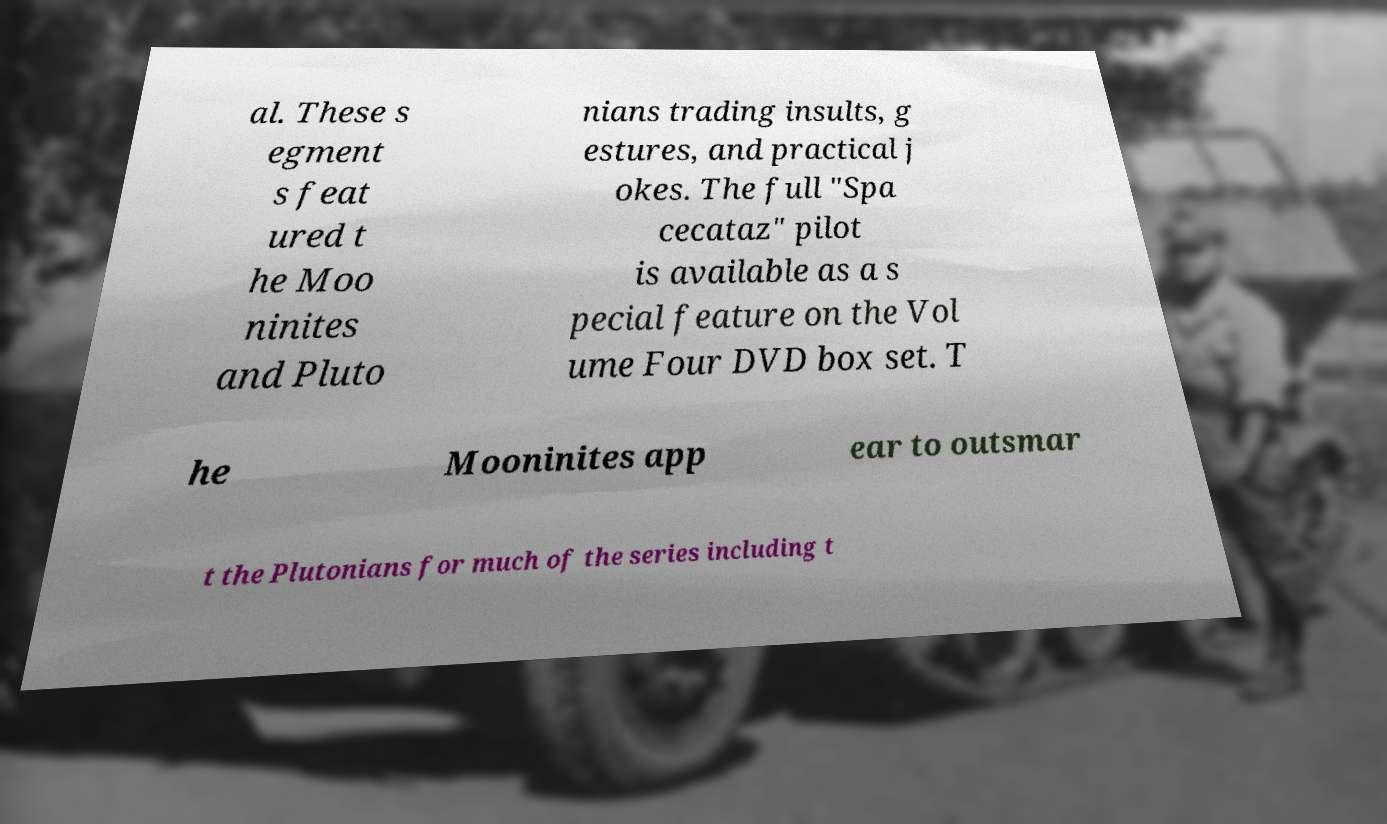I need the written content from this picture converted into text. Can you do that? al. These s egment s feat ured t he Moo ninites and Pluto nians trading insults, g estures, and practical j okes. The full "Spa cecataz" pilot is available as a s pecial feature on the Vol ume Four DVD box set. T he Mooninites app ear to outsmar t the Plutonians for much of the series including t 